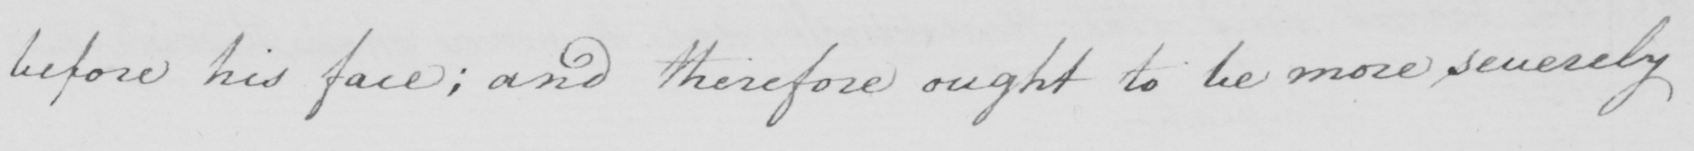Please provide the text content of this handwritten line. before his face ; and therefore ought to be more severely 